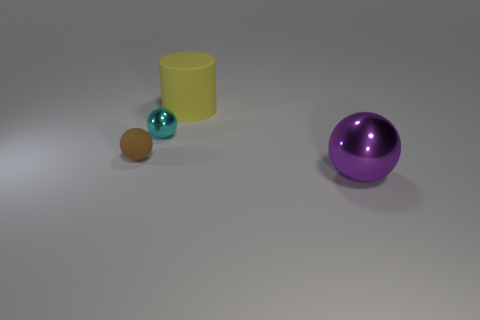How many objects are metal balls behind the big shiny ball or big purple spheres?
Offer a very short reply. 2. Do the metal ball that is on the right side of the cylinder and the cylinder have the same size?
Your answer should be very brief. Yes. Is the number of big purple metallic objects behind the big metallic ball less than the number of large rubber cylinders?
Your response must be concise. Yes. What material is the purple thing that is the same size as the cylinder?
Provide a short and direct response. Metal. How many large objects are cyan things or matte objects?
Offer a terse response. 1. What number of things are big things that are to the left of the purple ball or things that are in front of the large cylinder?
Offer a very short reply. 4. Is the number of big blue matte things less than the number of rubber cylinders?
Offer a terse response. Yes. There is a thing that is the same size as the yellow rubber cylinder; what is its shape?
Make the answer very short. Sphere. How many small things are there?
Provide a short and direct response. 2. What number of balls are both behind the small brown rubber thing and in front of the small brown matte sphere?
Offer a very short reply. 0. 